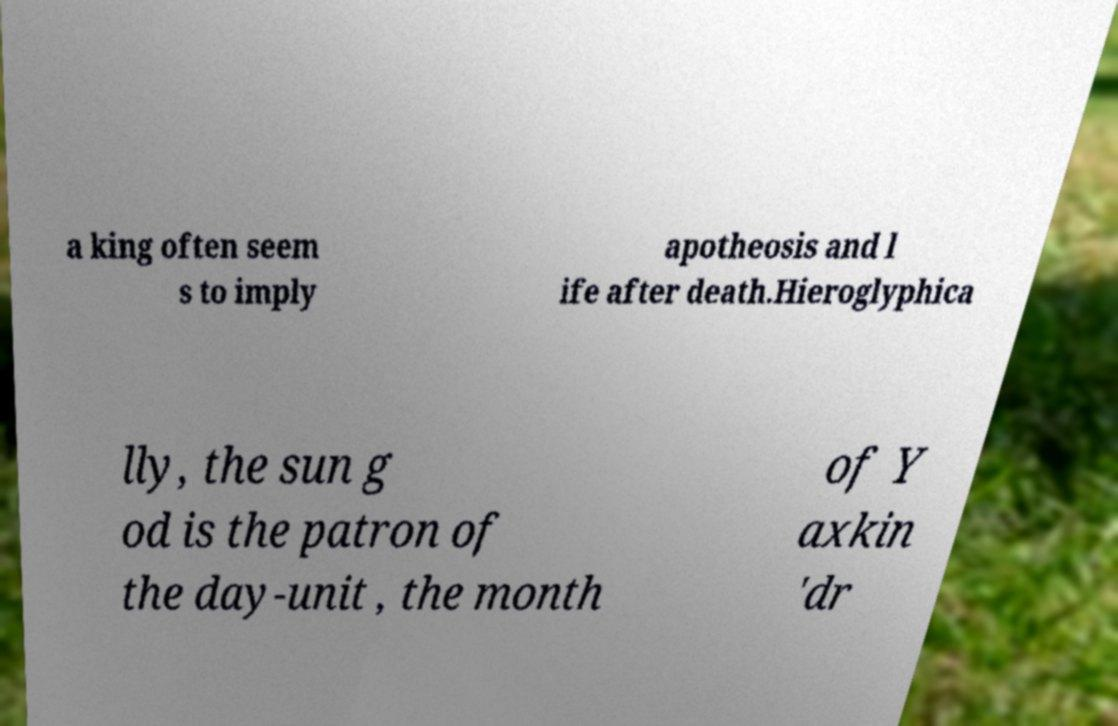I need the written content from this picture converted into text. Can you do that? a king often seem s to imply apotheosis and l ife after death.Hieroglyphica lly, the sun g od is the patron of the day-unit , the month of Y axkin 'dr 